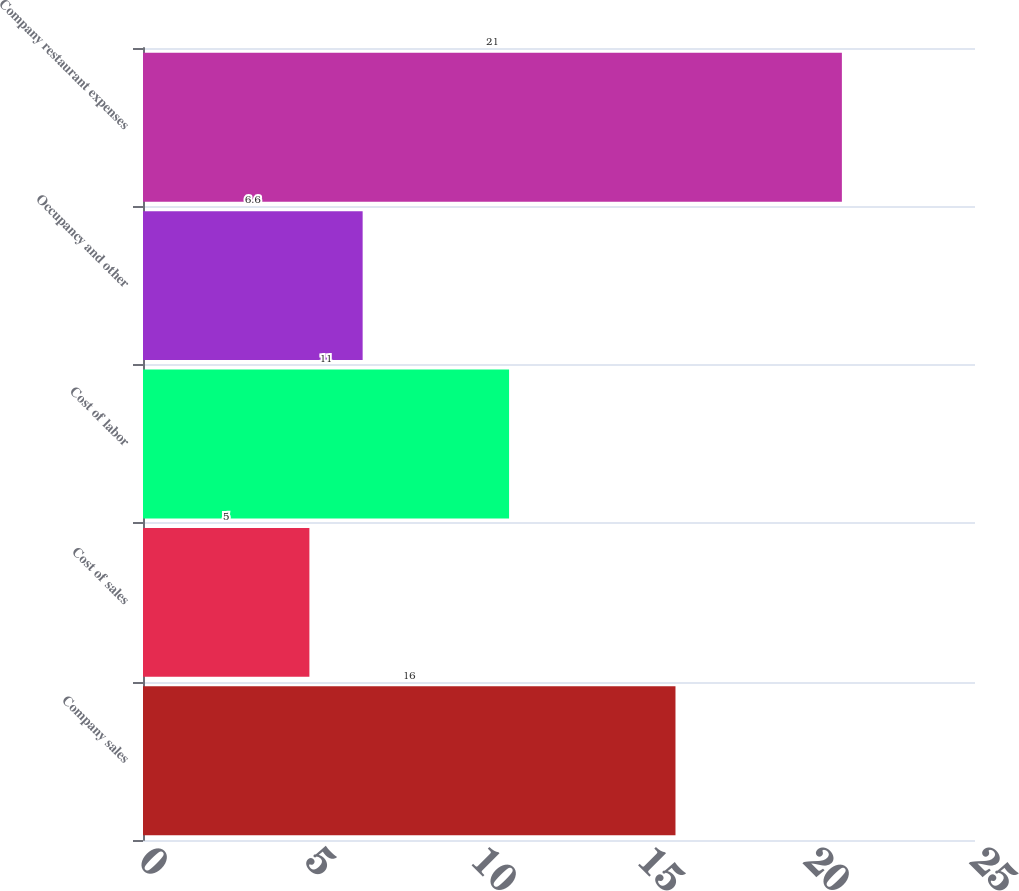<chart> <loc_0><loc_0><loc_500><loc_500><bar_chart><fcel>Company sales<fcel>Cost of sales<fcel>Cost of labor<fcel>Occupancy and other<fcel>Company restaurant expenses<nl><fcel>16<fcel>5<fcel>11<fcel>6.6<fcel>21<nl></chart> 